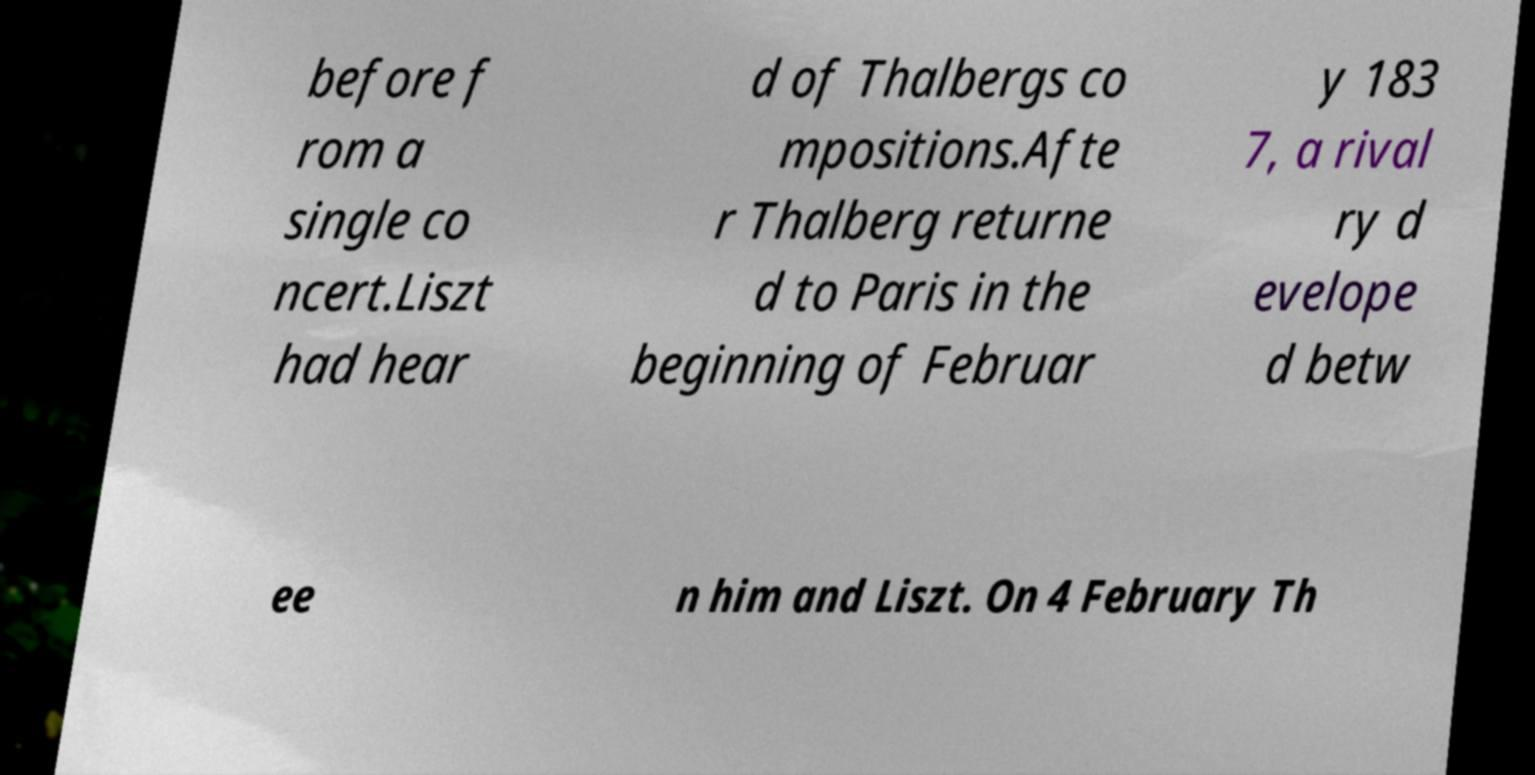I need the written content from this picture converted into text. Can you do that? before f rom a single co ncert.Liszt had hear d of Thalbergs co mpositions.Afte r Thalberg returne d to Paris in the beginning of Februar y 183 7, a rival ry d evelope d betw ee n him and Liszt. On 4 February Th 